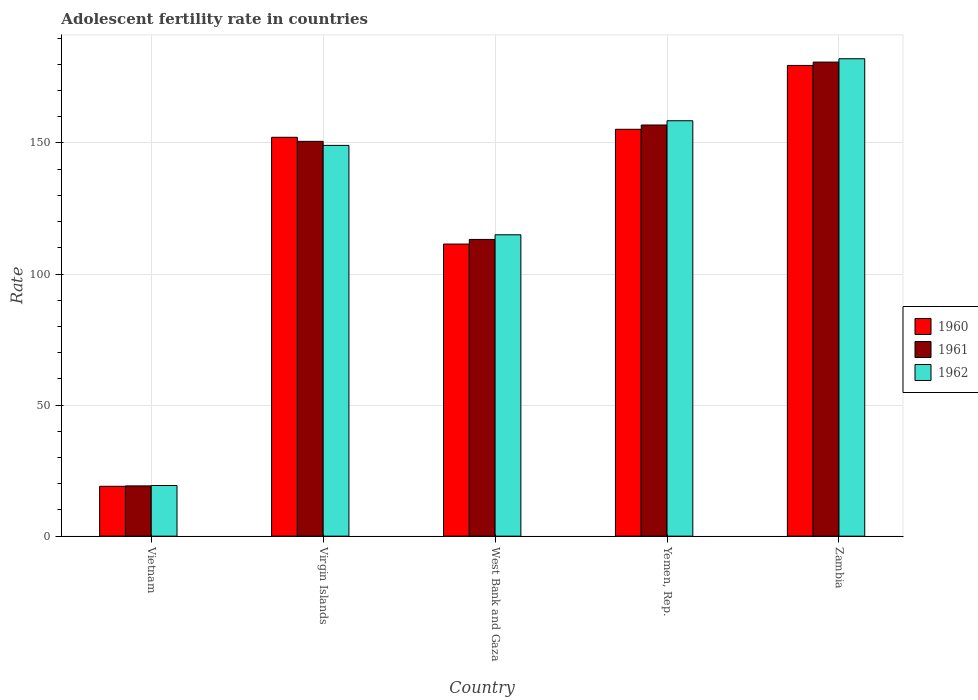How many groups of bars are there?
Provide a short and direct response. 5. Are the number of bars per tick equal to the number of legend labels?
Your response must be concise. Yes. How many bars are there on the 3rd tick from the left?
Make the answer very short. 3. How many bars are there on the 2nd tick from the right?
Your response must be concise. 3. What is the label of the 3rd group of bars from the left?
Your answer should be very brief. West Bank and Gaza. In how many cases, is the number of bars for a given country not equal to the number of legend labels?
Provide a short and direct response. 0. What is the adolescent fertility rate in 1960 in West Bank and Gaza?
Your response must be concise. 111.43. Across all countries, what is the maximum adolescent fertility rate in 1960?
Provide a short and direct response. 179.58. Across all countries, what is the minimum adolescent fertility rate in 1962?
Your answer should be very brief. 19.33. In which country was the adolescent fertility rate in 1961 maximum?
Provide a short and direct response. Zambia. In which country was the adolescent fertility rate in 1962 minimum?
Your answer should be very brief. Vietnam. What is the total adolescent fertility rate in 1961 in the graph?
Offer a very short reply. 620.69. What is the difference between the adolescent fertility rate in 1962 in Virgin Islands and that in West Bank and Gaza?
Your answer should be compact. 34.1. What is the difference between the adolescent fertility rate in 1960 in Zambia and the adolescent fertility rate in 1961 in West Bank and Gaza?
Your response must be concise. 66.38. What is the average adolescent fertility rate in 1962 per country?
Ensure brevity in your answer.  124.79. What is the difference between the adolescent fertility rate of/in 1962 and adolescent fertility rate of/in 1960 in Virgin Islands?
Provide a succinct answer. -3.09. What is the ratio of the adolescent fertility rate in 1960 in Virgin Islands to that in West Bank and Gaza?
Your answer should be very brief. 1.37. Is the difference between the adolescent fertility rate in 1962 in Virgin Islands and Zambia greater than the difference between the adolescent fertility rate in 1960 in Virgin Islands and Zambia?
Keep it short and to the point. No. What is the difference between the highest and the second highest adolescent fertility rate in 1962?
Your response must be concise. 9.41. What is the difference between the highest and the lowest adolescent fertility rate in 1960?
Give a very brief answer. 160.55. What does the 1st bar from the left in Yemen, Rep. represents?
Offer a very short reply. 1960. Are all the bars in the graph horizontal?
Your response must be concise. No. What is the difference between two consecutive major ticks on the Y-axis?
Provide a short and direct response. 50. Does the graph contain grids?
Make the answer very short. Yes. What is the title of the graph?
Give a very brief answer. Adolescent fertility rate in countries. What is the label or title of the Y-axis?
Offer a very short reply. Rate. What is the Rate in 1960 in Vietnam?
Your response must be concise. 19.03. What is the Rate in 1961 in Vietnam?
Your response must be concise. 19.18. What is the Rate of 1962 in Vietnam?
Make the answer very short. 19.33. What is the Rate of 1960 in Virgin Islands?
Keep it short and to the point. 152.16. What is the Rate of 1961 in Virgin Islands?
Provide a succinct answer. 150.61. What is the Rate in 1962 in Virgin Islands?
Your response must be concise. 149.07. What is the Rate of 1960 in West Bank and Gaza?
Make the answer very short. 111.43. What is the Rate of 1961 in West Bank and Gaza?
Provide a succinct answer. 113.2. What is the Rate in 1962 in West Bank and Gaza?
Your response must be concise. 114.97. What is the Rate in 1960 in Yemen, Rep.?
Offer a very short reply. 155.21. What is the Rate of 1961 in Yemen, Rep.?
Make the answer very short. 156.85. What is the Rate in 1962 in Yemen, Rep.?
Keep it short and to the point. 158.48. What is the Rate in 1960 in Zambia?
Provide a short and direct response. 179.58. What is the Rate of 1961 in Zambia?
Offer a very short reply. 180.85. What is the Rate in 1962 in Zambia?
Offer a terse response. 182.12. Across all countries, what is the maximum Rate in 1960?
Give a very brief answer. 179.58. Across all countries, what is the maximum Rate of 1961?
Your answer should be compact. 180.85. Across all countries, what is the maximum Rate in 1962?
Make the answer very short. 182.12. Across all countries, what is the minimum Rate in 1960?
Offer a terse response. 19.03. Across all countries, what is the minimum Rate in 1961?
Provide a short and direct response. 19.18. Across all countries, what is the minimum Rate of 1962?
Keep it short and to the point. 19.33. What is the total Rate of 1960 in the graph?
Offer a terse response. 617.4. What is the total Rate in 1961 in the graph?
Provide a short and direct response. 620.69. What is the total Rate in 1962 in the graph?
Provide a short and direct response. 623.97. What is the difference between the Rate in 1960 in Vietnam and that in Virgin Islands?
Offer a very short reply. -133.13. What is the difference between the Rate in 1961 in Vietnam and that in Virgin Islands?
Ensure brevity in your answer.  -131.44. What is the difference between the Rate of 1962 in Vietnam and that in Virgin Islands?
Keep it short and to the point. -129.74. What is the difference between the Rate in 1960 in Vietnam and that in West Bank and Gaza?
Your answer should be compact. -92.41. What is the difference between the Rate in 1961 in Vietnam and that in West Bank and Gaza?
Make the answer very short. -94.02. What is the difference between the Rate in 1962 in Vietnam and that in West Bank and Gaza?
Offer a very short reply. -95.64. What is the difference between the Rate in 1960 in Vietnam and that in Yemen, Rep.?
Offer a terse response. -136.19. What is the difference between the Rate in 1961 in Vietnam and that in Yemen, Rep.?
Give a very brief answer. -137.67. What is the difference between the Rate of 1962 in Vietnam and that in Yemen, Rep.?
Provide a succinct answer. -139.14. What is the difference between the Rate in 1960 in Vietnam and that in Zambia?
Ensure brevity in your answer.  -160.55. What is the difference between the Rate in 1961 in Vietnam and that in Zambia?
Your answer should be very brief. -161.67. What is the difference between the Rate of 1962 in Vietnam and that in Zambia?
Ensure brevity in your answer.  -162.79. What is the difference between the Rate in 1960 in Virgin Islands and that in West Bank and Gaza?
Offer a very short reply. 40.73. What is the difference between the Rate in 1961 in Virgin Islands and that in West Bank and Gaza?
Offer a terse response. 37.41. What is the difference between the Rate in 1962 in Virgin Islands and that in West Bank and Gaza?
Make the answer very short. 34.1. What is the difference between the Rate of 1960 in Virgin Islands and that in Yemen, Rep.?
Give a very brief answer. -3.06. What is the difference between the Rate in 1961 in Virgin Islands and that in Yemen, Rep.?
Make the answer very short. -6.23. What is the difference between the Rate in 1962 in Virgin Islands and that in Yemen, Rep.?
Your answer should be compact. -9.41. What is the difference between the Rate of 1960 in Virgin Islands and that in Zambia?
Make the answer very short. -27.42. What is the difference between the Rate of 1961 in Virgin Islands and that in Zambia?
Give a very brief answer. -30.24. What is the difference between the Rate in 1962 in Virgin Islands and that in Zambia?
Offer a very short reply. -33.05. What is the difference between the Rate of 1960 in West Bank and Gaza and that in Yemen, Rep.?
Provide a succinct answer. -43.78. What is the difference between the Rate in 1961 in West Bank and Gaza and that in Yemen, Rep.?
Make the answer very short. -43.65. What is the difference between the Rate of 1962 in West Bank and Gaza and that in Yemen, Rep.?
Your answer should be compact. -43.51. What is the difference between the Rate in 1960 in West Bank and Gaza and that in Zambia?
Provide a succinct answer. -68.15. What is the difference between the Rate in 1961 in West Bank and Gaza and that in Zambia?
Offer a terse response. -67.65. What is the difference between the Rate of 1962 in West Bank and Gaza and that in Zambia?
Your answer should be very brief. -67.16. What is the difference between the Rate in 1960 in Yemen, Rep. and that in Zambia?
Give a very brief answer. -24.36. What is the difference between the Rate of 1961 in Yemen, Rep. and that in Zambia?
Your answer should be compact. -24. What is the difference between the Rate of 1962 in Yemen, Rep. and that in Zambia?
Your answer should be very brief. -23.65. What is the difference between the Rate of 1960 in Vietnam and the Rate of 1961 in Virgin Islands?
Offer a very short reply. -131.59. What is the difference between the Rate of 1960 in Vietnam and the Rate of 1962 in Virgin Islands?
Your answer should be very brief. -130.04. What is the difference between the Rate in 1961 in Vietnam and the Rate in 1962 in Virgin Islands?
Make the answer very short. -129.89. What is the difference between the Rate in 1960 in Vietnam and the Rate in 1961 in West Bank and Gaza?
Make the answer very short. -94.17. What is the difference between the Rate in 1960 in Vietnam and the Rate in 1962 in West Bank and Gaza?
Provide a short and direct response. -95.94. What is the difference between the Rate in 1961 in Vietnam and the Rate in 1962 in West Bank and Gaza?
Make the answer very short. -95.79. What is the difference between the Rate of 1960 in Vietnam and the Rate of 1961 in Yemen, Rep.?
Your answer should be compact. -137.82. What is the difference between the Rate of 1960 in Vietnam and the Rate of 1962 in Yemen, Rep.?
Your answer should be very brief. -139.45. What is the difference between the Rate of 1961 in Vietnam and the Rate of 1962 in Yemen, Rep.?
Give a very brief answer. -139.3. What is the difference between the Rate of 1960 in Vietnam and the Rate of 1961 in Zambia?
Offer a very short reply. -161.82. What is the difference between the Rate of 1960 in Vietnam and the Rate of 1962 in Zambia?
Your answer should be compact. -163.1. What is the difference between the Rate of 1961 in Vietnam and the Rate of 1962 in Zambia?
Offer a terse response. -162.94. What is the difference between the Rate in 1960 in Virgin Islands and the Rate in 1961 in West Bank and Gaza?
Provide a succinct answer. 38.96. What is the difference between the Rate in 1960 in Virgin Islands and the Rate in 1962 in West Bank and Gaza?
Provide a succinct answer. 37.19. What is the difference between the Rate in 1961 in Virgin Islands and the Rate in 1962 in West Bank and Gaza?
Give a very brief answer. 35.65. What is the difference between the Rate in 1960 in Virgin Islands and the Rate in 1961 in Yemen, Rep.?
Provide a succinct answer. -4.69. What is the difference between the Rate in 1960 in Virgin Islands and the Rate in 1962 in Yemen, Rep.?
Give a very brief answer. -6.32. What is the difference between the Rate of 1961 in Virgin Islands and the Rate of 1962 in Yemen, Rep.?
Provide a short and direct response. -7.86. What is the difference between the Rate of 1960 in Virgin Islands and the Rate of 1961 in Zambia?
Your answer should be very brief. -28.69. What is the difference between the Rate of 1960 in Virgin Islands and the Rate of 1962 in Zambia?
Your answer should be very brief. -29.96. What is the difference between the Rate in 1961 in Virgin Islands and the Rate in 1962 in Zambia?
Offer a very short reply. -31.51. What is the difference between the Rate in 1960 in West Bank and Gaza and the Rate in 1961 in Yemen, Rep.?
Your response must be concise. -45.41. What is the difference between the Rate in 1960 in West Bank and Gaza and the Rate in 1962 in Yemen, Rep.?
Offer a terse response. -47.05. What is the difference between the Rate of 1961 in West Bank and Gaza and the Rate of 1962 in Yemen, Rep.?
Give a very brief answer. -45.28. What is the difference between the Rate in 1960 in West Bank and Gaza and the Rate in 1961 in Zambia?
Offer a very short reply. -69.42. What is the difference between the Rate in 1960 in West Bank and Gaza and the Rate in 1962 in Zambia?
Offer a very short reply. -70.69. What is the difference between the Rate of 1961 in West Bank and Gaza and the Rate of 1962 in Zambia?
Your answer should be very brief. -68.92. What is the difference between the Rate of 1960 in Yemen, Rep. and the Rate of 1961 in Zambia?
Give a very brief answer. -25.64. What is the difference between the Rate in 1960 in Yemen, Rep. and the Rate in 1962 in Zambia?
Give a very brief answer. -26.91. What is the difference between the Rate of 1961 in Yemen, Rep. and the Rate of 1962 in Zambia?
Ensure brevity in your answer.  -25.28. What is the average Rate of 1960 per country?
Your answer should be very brief. 123.48. What is the average Rate in 1961 per country?
Offer a terse response. 124.14. What is the average Rate of 1962 per country?
Your answer should be compact. 124.79. What is the difference between the Rate of 1960 and Rate of 1961 in Vietnam?
Give a very brief answer. -0.15. What is the difference between the Rate in 1960 and Rate in 1962 in Vietnam?
Make the answer very short. -0.31. What is the difference between the Rate in 1961 and Rate in 1962 in Vietnam?
Provide a short and direct response. -0.15. What is the difference between the Rate of 1960 and Rate of 1961 in Virgin Islands?
Give a very brief answer. 1.54. What is the difference between the Rate of 1960 and Rate of 1962 in Virgin Islands?
Make the answer very short. 3.09. What is the difference between the Rate of 1961 and Rate of 1962 in Virgin Islands?
Give a very brief answer. 1.54. What is the difference between the Rate in 1960 and Rate in 1961 in West Bank and Gaza?
Offer a very short reply. -1.77. What is the difference between the Rate in 1960 and Rate in 1962 in West Bank and Gaza?
Your answer should be compact. -3.54. What is the difference between the Rate of 1961 and Rate of 1962 in West Bank and Gaza?
Offer a terse response. -1.77. What is the difference between the Rate in 1960 and Rate in 1961 in Yemen, Rep.?
Your response must be concise. -1.63. What is the difference between the Rate in 1960 and Rate in 1962 in Yemen, Rep.?
Give a very brief answer. -3.26. What is the difference between the Rate of 1961 and Rate of 1962 in Yemen, Rep.?
Your response must be concise. -1.63. What is the difference between the Rate of 1960 and Rate of 1961 in Zambia?
Make the answer very short. -1.27. What is the difference between the Rate of 1960 and Rate of 1962 in Zambia?
Ensure brevity in your answer.  -2.55. What is the difference between the Rate in 1961 and Rate in 1962 in Zambia?
Your answer should be compact. -1.27. What is the ratio of the Rate of 1960 in Vietnam to that in Virgin Islands?
Your answer should be very brief. 0.12. What is the ratio of the Rate of 1961 in Vietnam to that in Virgin Islands?
Your answer should be very brief. 0.13. What is the ratio of the Rate of 1962 in Vietnam to that in Virgin Islands?
Provide a succinct answer. 0.13. What is the ratio of the Rate of 1960 in Vietnam to that in West Bank and Gaza?
Make the answer very short. 0.17. What is the ratio of the Rate in 1961 in Vietnam to that in West Bank and Gaza?
Keep it short and to the point. 0.17. What is the ratio of the Rate in 1962 in Vietnam to that in West Bank and Gaza?
Your response must be concise. 0.17. What is the ratio of the Rate in 1960 in Vietnam to that in Yemen, Rep.?
Make the answer very short. 0.12. What is the ratio of the Rate in 1961 in Vietnam to that in Yemen, Rep.?
Provide a succinct answer. 0.12. What is the ratio of the Rate of 1962 in Vietnam to that in Yemen, Rep.?
Your answer should be very brief. 0.12. What is the ratio of the Rate in 1960 in Vietnam to that in Zambia?
Keep it short and to the point. 0.11. What is the ratio of the Rate of 1961 in Vietnam to that in Zambia?
Make the answer very short. 0.11. What is the ratio of the Rate of 1962 in Vietnam to that in Zambia?
Provide a succinct answer. 0.11. What is the ratio of the Rate of 1960 in Virgin Islands to that in West Bank and Gaza?
Your answer should be very brief. 1.37. What is the ratio of the Rate of 1961 in Virgin Islands to that in West Bank and Gaza?
Provide a short and direct response. 1.33. What is the ratio of the Rate in 1962 in Virgin Islands to that in West Bank and Gaza?
Provide a succinct answer. 1.3. What is the ratio of the Rate in 1960 in Virgin Islands to that in Yemen, Rep.?
Make the answer very short. 0.98. What is the ratio of the Rate in 1961 in Virgin Islands to that in Yemen, Rep.?
Offer a terse response. 0.96. What is the ratio of the Rate in 1962 in Virgin Islands to that in Yemen, Rep.?
Provide a short and direct response. 0.94. What is the ratio of the Rate of 1960 in Virgin Islands to that in Zambia?
Your answer should be very brief. 0.85. What is the ratio of the Rate in 1961 in Virgin Islands to that in Zambia?
Give a very brief answer. 0.83. What is the ratio of the Rate in 1962 in Virgin Islands to that in Zambia?
Provide a succinct answer. 0.82. What is the ratio of the Rate of 1960 in West Bank and Gaza to that in Yemen, Rep.?
Give a very brief answer. 0.72. What is the ratio of the Rate in 1961 in West Bank and Gaza to that in Yemen, Rep.?
Make the answer very short. 0.72. What is the ratio of the Rate of 1962 in West Bank and Gaza to that in Yemen, Rep.?
Keep it short and to the point. 0.73. What is the ratio of the Rate in 1960 in West Bank and Gaza to that in Zambia?
Provide a short and direct response. 0.62. What is the ratio of the Rate of 1961 in West Bank and Gaza to that in Zambia?
Provide a short and direct response. 0.63. What is the ratio of the Rate of 1962 in West Bank and Gaza to that in Zambia?
Keep it short and to the point. 0.63. What is the ratio of the Rate in 1960 in Yemen, Rep. to that in Zambia?
Offer a very short reply. 0.86. What is the ratio of the Rate in 1961 in Yemen, Rep. to that in Zambia?
Keep it short and to the point. 0.87. What is the ratio of the Rate in 1962 in Yemen, Rep. to that in Zambia?
Provide a succinct answer. 0.87. What is the difference between the highest and the second highest Rate of 1960?
Your answer should be very brief. 24.36. What is the difference between the highest and the second highest Rate in 1961?
Give a very brief answer. 24. What is the difference between the highest and the second highest Rate of 1962?
Provide a succinct answer. 23.65. What is the difference between the highest and the lowest Rate of 1960?
Make the answer very short. 160.55. What is the difference between the highest and the lowest Rate in 1961?
Offer a terse response. 161.67. What is the difference between the highest and the lowest Rate of 1962?
Make the answer very short. 162.79. 